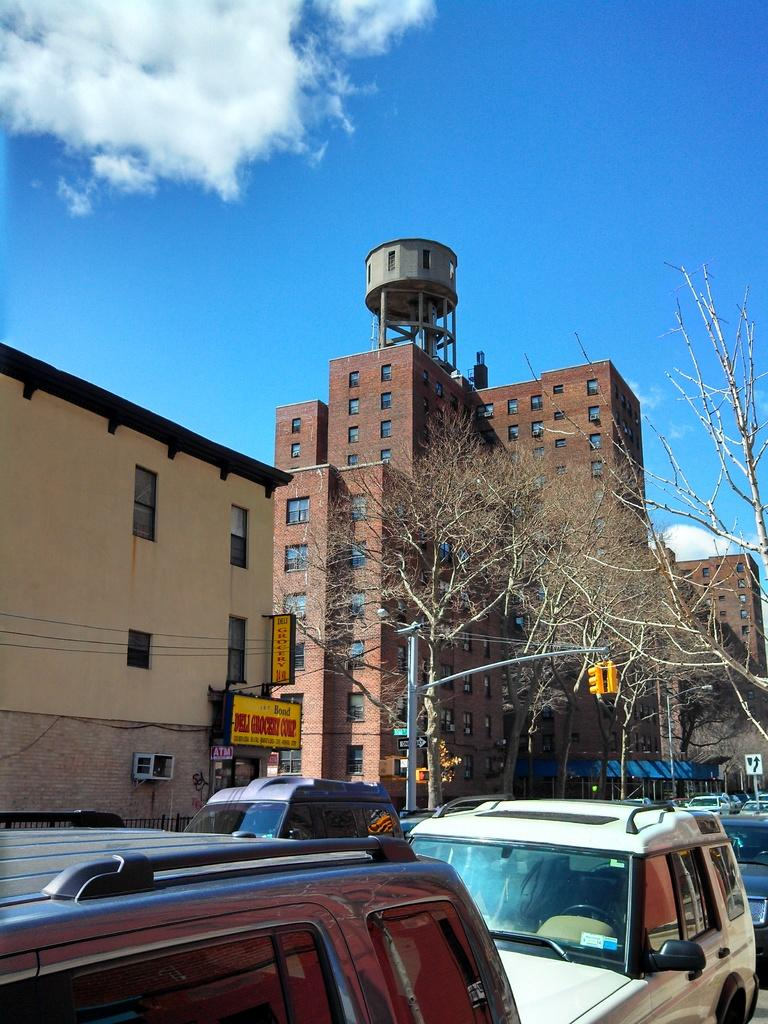What can be seen in the image? There are vehicles in the image. What is visible in the background of the image? In the background, there are dried trees, buildings, boards, and traffic signals. What is the color of the sky in the image? The sky is blue and white in color. How does the baby contribute to the force in the image? There is no baby present in the image, so it cannot contribute to any force. 